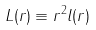<formula> <loc_0><loc_0><loc_500><loc_500>L ( r ) \equiv r ^ { 2 } l ( r )</formula> 